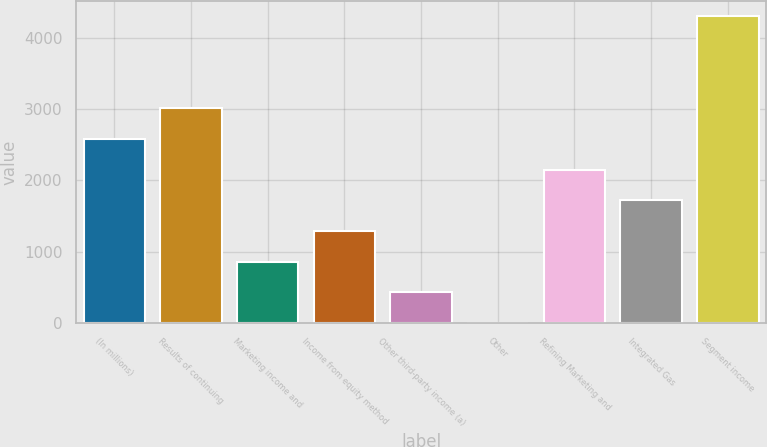Convert chart. <chart><loc_0><loc_0><loc_500><loc_500><bar_chart><fcel>(In millions)<fcel>Results of continuing<fcel>Marketing income and<fcel>Income from equity method<fcel>Other third-party income (a)<fcel>Other<fcel>Refining Marketing and<fcel>Integrated Gas<fcel>Segment income<nl><fcel>2579.4<fcel>3008.3<fcel>863.8<fcel>1292.7<fcel>434.9<fcel>6<fcel>2150.5<fcel>1721.6<fcel>4295<nl></chart> 